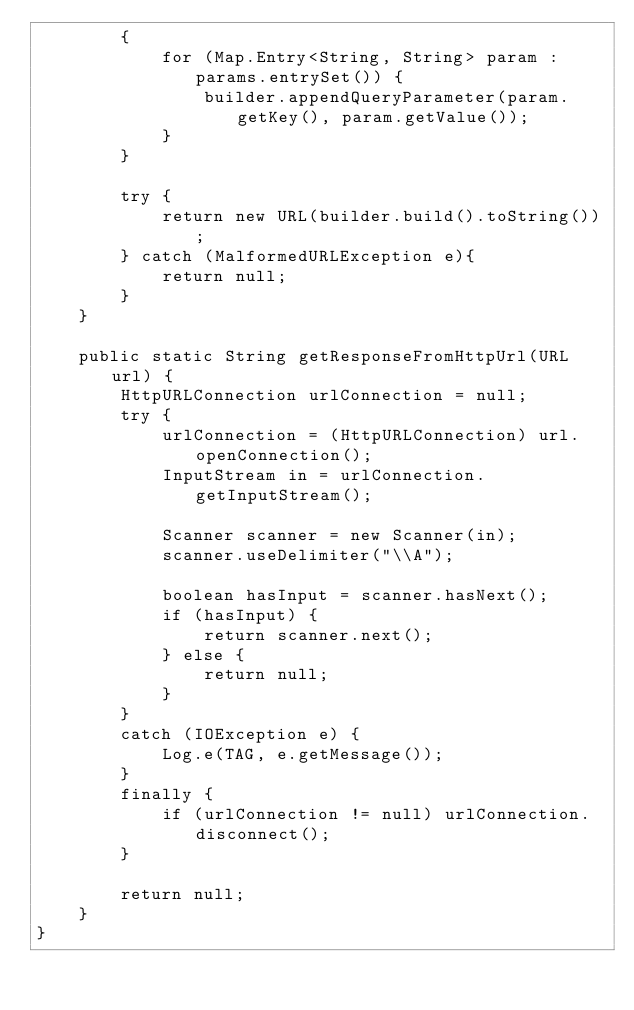Convert code to text. <code><loc_0><loc_0><loc_500><loc_500><_Java_>        {
            for (Map.Entry<String, String> param : params.entrySet()) {
                builder.appendQueryParameter(param.getKey(), param.getValue());
            }
        }

        try {
            return new URL(builder.build().toString());
        } catch (MalformedURLException e){
            return null;
        }
    }

    public static String getResponseFromHttpUrl(URL url) {
        HttpURLConnection urlConnection = null;
        try {
            urlConnection = (HttpURLConnection) url.openConnection();
            InputStream in = urlConnection.getInputStream();

            Scanner scanner = new Scanner(in);
            scanner.useDelimiter("\\A");

            boolean hasInput = scanner.hasNext();
            if (hasInput) {
                return scanner.next();
            } else {
                return null;
            }
        }
        catch (IOException e) {
            Log.e(TAG, e.getMessage());
        }
        finally {
            if (urlConnection != null) urlConnection.disconnect();
        }

        return null;
    }
}
</code> 